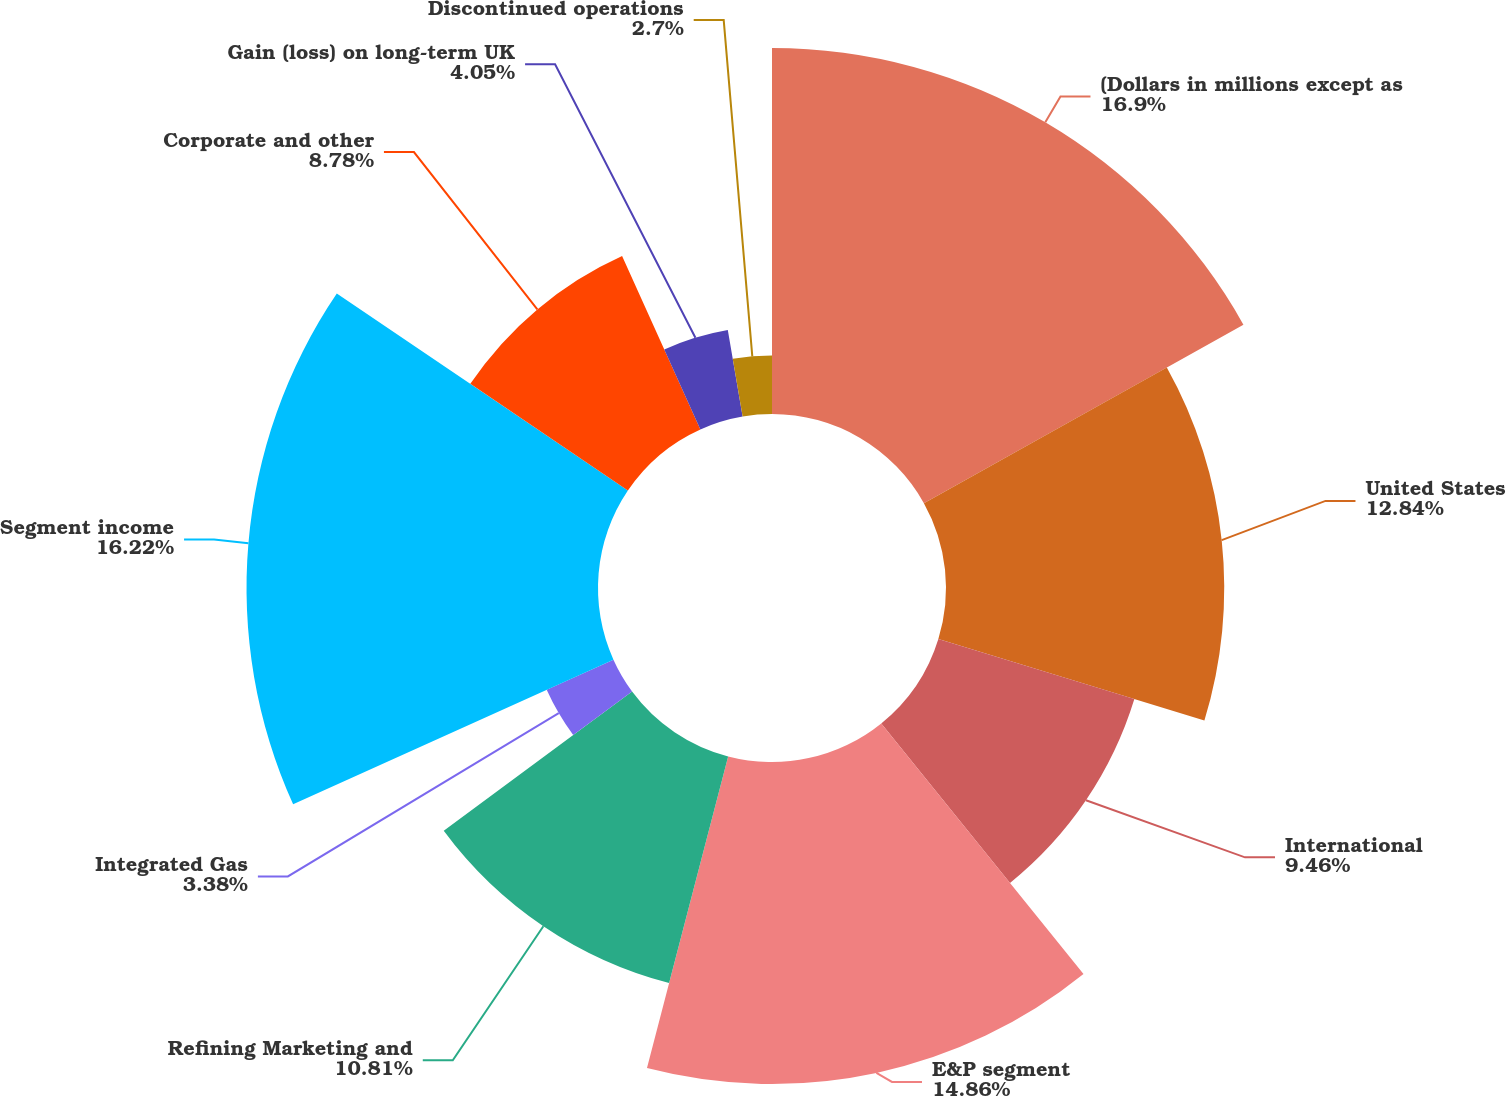<chart> <loc_0><loc_0><loc_500><loc_500><pie_chart><fcel>(Dollars in millions except as<fcel>United States<fcel>International<fcel>E&P segment<fcel>Refining Marketing and<fcel>Integrated Gas<fcel>Segment income<fcel>Corporate and other<fcel>Gain (loss) on long-term UK<fcel>Discontinued operations<nl><fcel>16.89%<fcel>12.84%<fcel>9.46%<fcel>14.86%<fcel>10.81%<fcel>3.38%<fcel>16.22%<fcel>8.78%<fcel>4.05%<fcel>2.7%<nl></chart> 